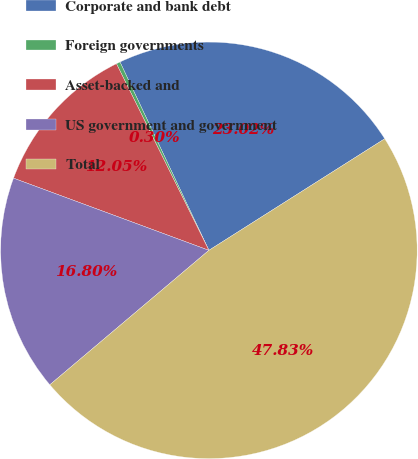Convert chart to OTSL. <chart><loc_0><loc_0><loc_500><loc_500><pie_chart><fcel>Corporate and bank debt<fcel>Foreign governments<fcel>Asset-backed and<fcel>US government and government<fcel>Total<nl><fcel>23.02%<fcel>0.3%<fcel>12.05%<fcel>16.8%<fcel>47.83%<nl></chart> 